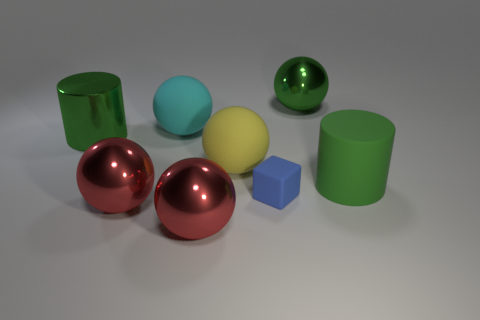What number of other objects are the same size as the yellow matte thing?
Provide a succinct answer. 6. Are any tiny metallic blocks visible?
Your answer should be compact. No. There is a thing that is to the right of the shiny ball that is behind the big rubber cylinder; what is its size?
Provide a succinct answer. Large. There is a large cylinder that is left of the tiny blue block; does it have the same color as the shiny sphere behind the rubber cylinder?
Your answer should be very brief. Yes. What color is the large shiny object that is both behind the yellow sphere and to the left of the big green metal sphere?
Ensure brevity in your answer.  Green. What number of other things are the same shape as the big yellow thing?
Provide a succinct answer. 4. The matte ball that is the same size as the cyan rubber object is what color?
Offer a terse response. Yellow. What color is the big thing that is right of the large green ball?
Provide a short and direct response. Green. There is a big red thing on the right side of the large cyan ball; is there a big green thing on the left side of it?
Provide a short and direct response. Yes. Is the shape of the green matte thing the same as the big green shiny object that is on the left side of the green shiny sphere?
Ensure brevity in your answer.  Yes. 